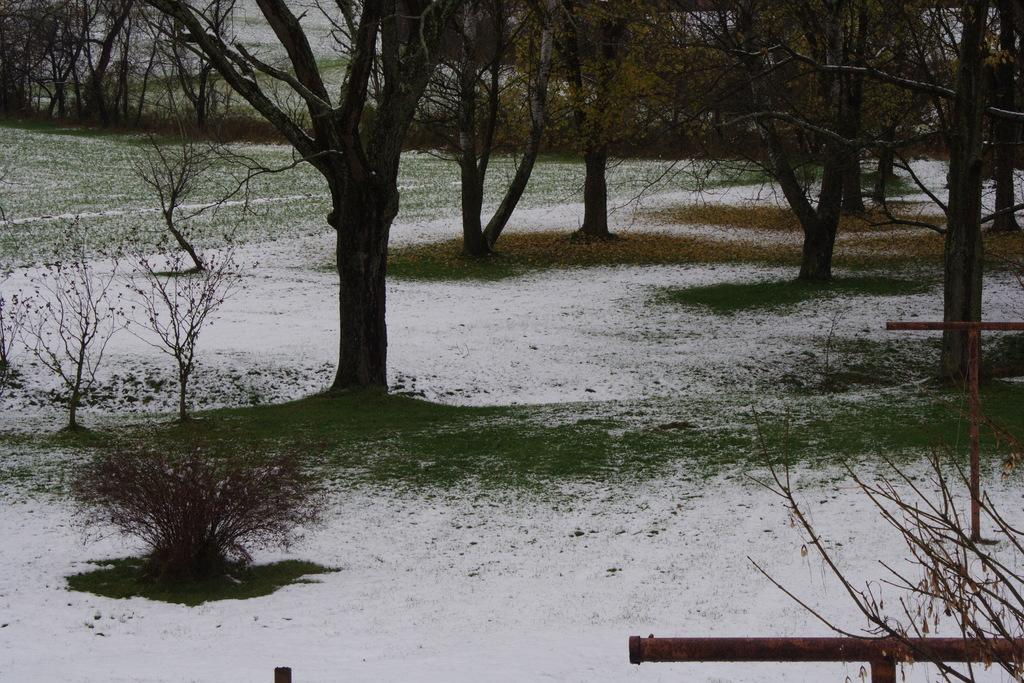What type of vegetation can be seen in the image? There are plants, trees, and grass in the image. Can you describe the different types of vegetation present? The image contains plants, which could be flowers or shrubs, trees, and grass. What is the natural environment depicted in the image? The image shows a natural environment with plants, trees, and grass. What type of hat is the bear wearing in the image? There is no bear or hat present in the image; it only contains plants, trees, and grass. 